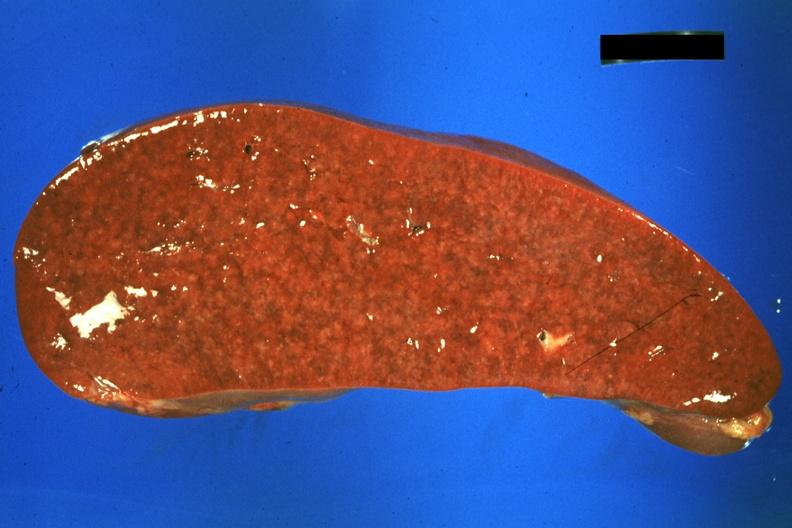s glomerulosa present?
Answer the question using a single word or phrase. No 